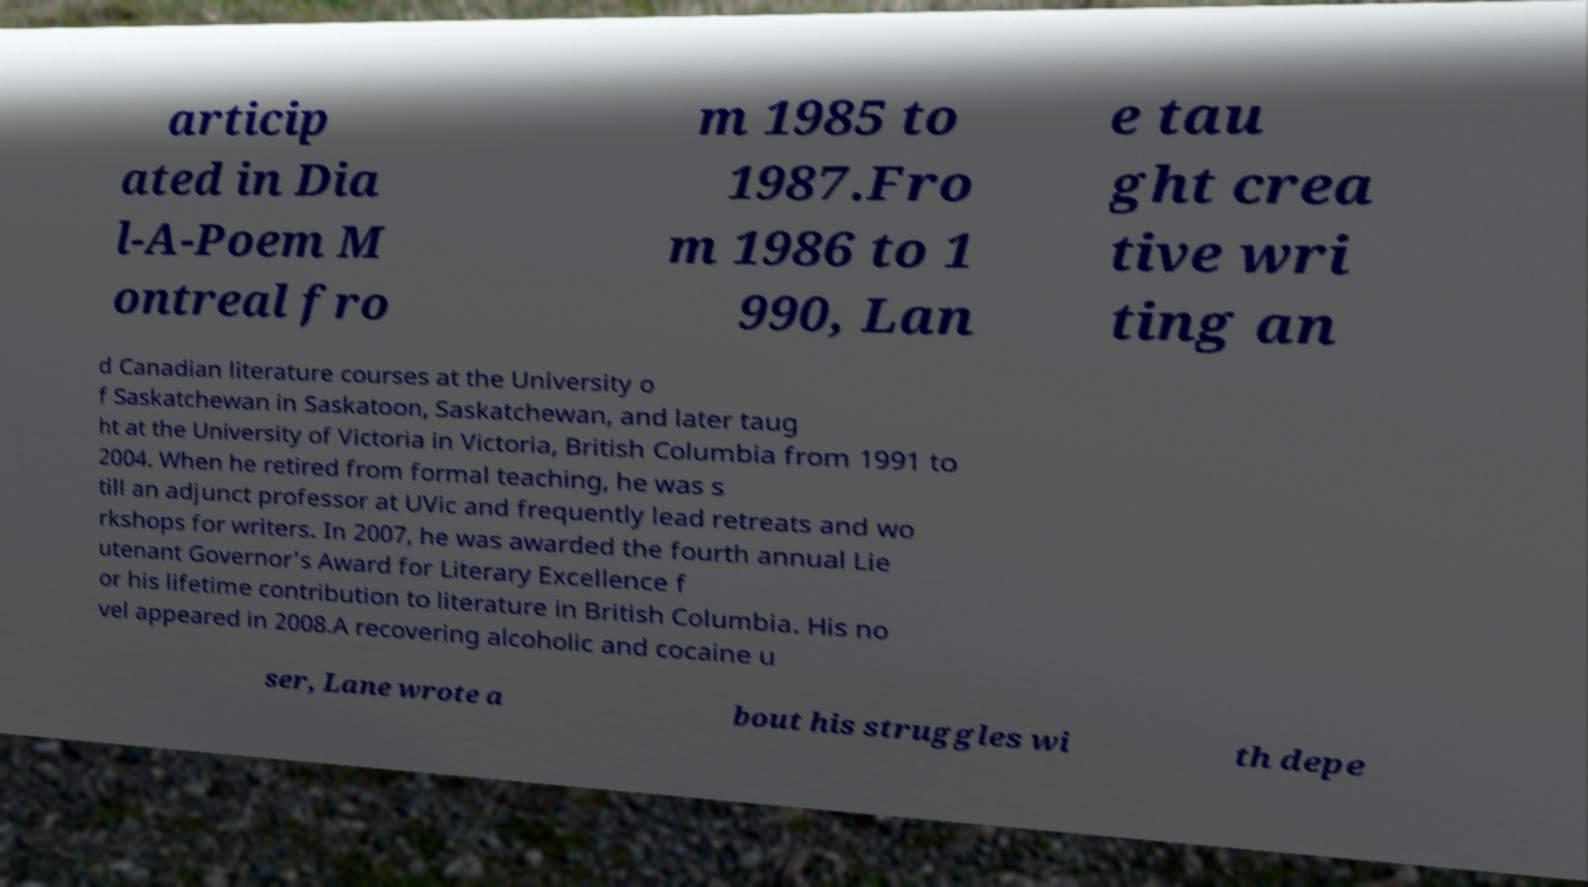Could you extract and type out the text from this image? articip ated in Dia l-A-Poem M ontreal fro m 1985 to 1987.Fro m 1986 to 1 990, Lan e tau ght crea tive wri ting an d Canadian literature courses at the University o f Saskatchewan in Saskatoon, Saskatchewan, and later taug ht at the University of Victoria in Victoria, British Columbia from 1991 to 2004. When he retired from formal teaching, he was s till an adjunct professor at UVic and frequently lead retreats and wo rkshops for writers. In 2007, he was awarded the fourth annual Lie utenant Governor's Award for Literary Excellence f or his lifetime contribution to literature in British Columbia. His no vel appeared in 2008.A recovering alcoholic and cocaine u ser, Lane wrote a bout his struggles wi th depe 